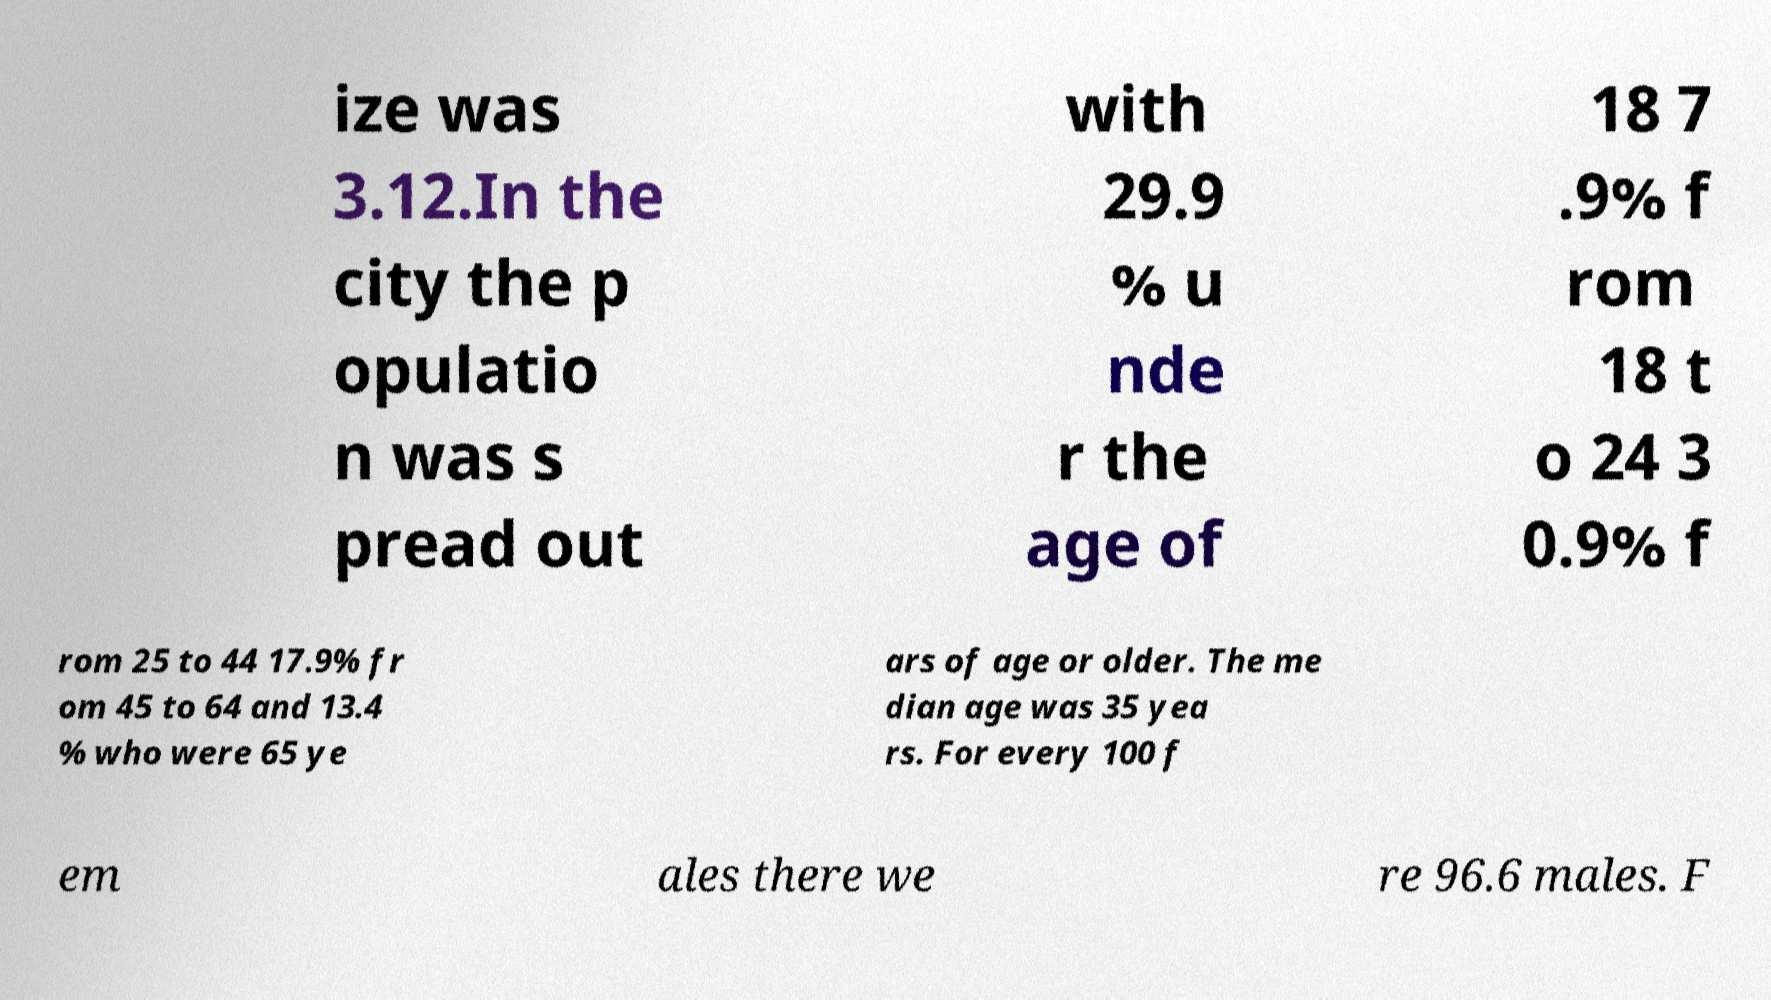Could you assist in decoding the text presented in this image and type it out clearly? ize was 3.12.In the city the p opulatio n was s pread out with 29.9 % u nde r the age of 18 7 .9% f rom 18 t o 24 3 0.9% f rom 25 to 44 17.9% fr om 45 to 64 and 13.4 % who were 65 ye ars of age or older. The me dian age was 35 yea rs. For every 100 f em ales there we re 96.6 males. F 